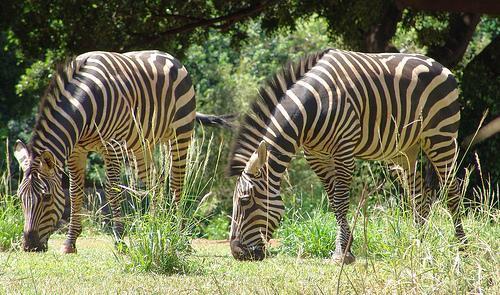How many zebras are there?
Give a very brief answer. 2. 